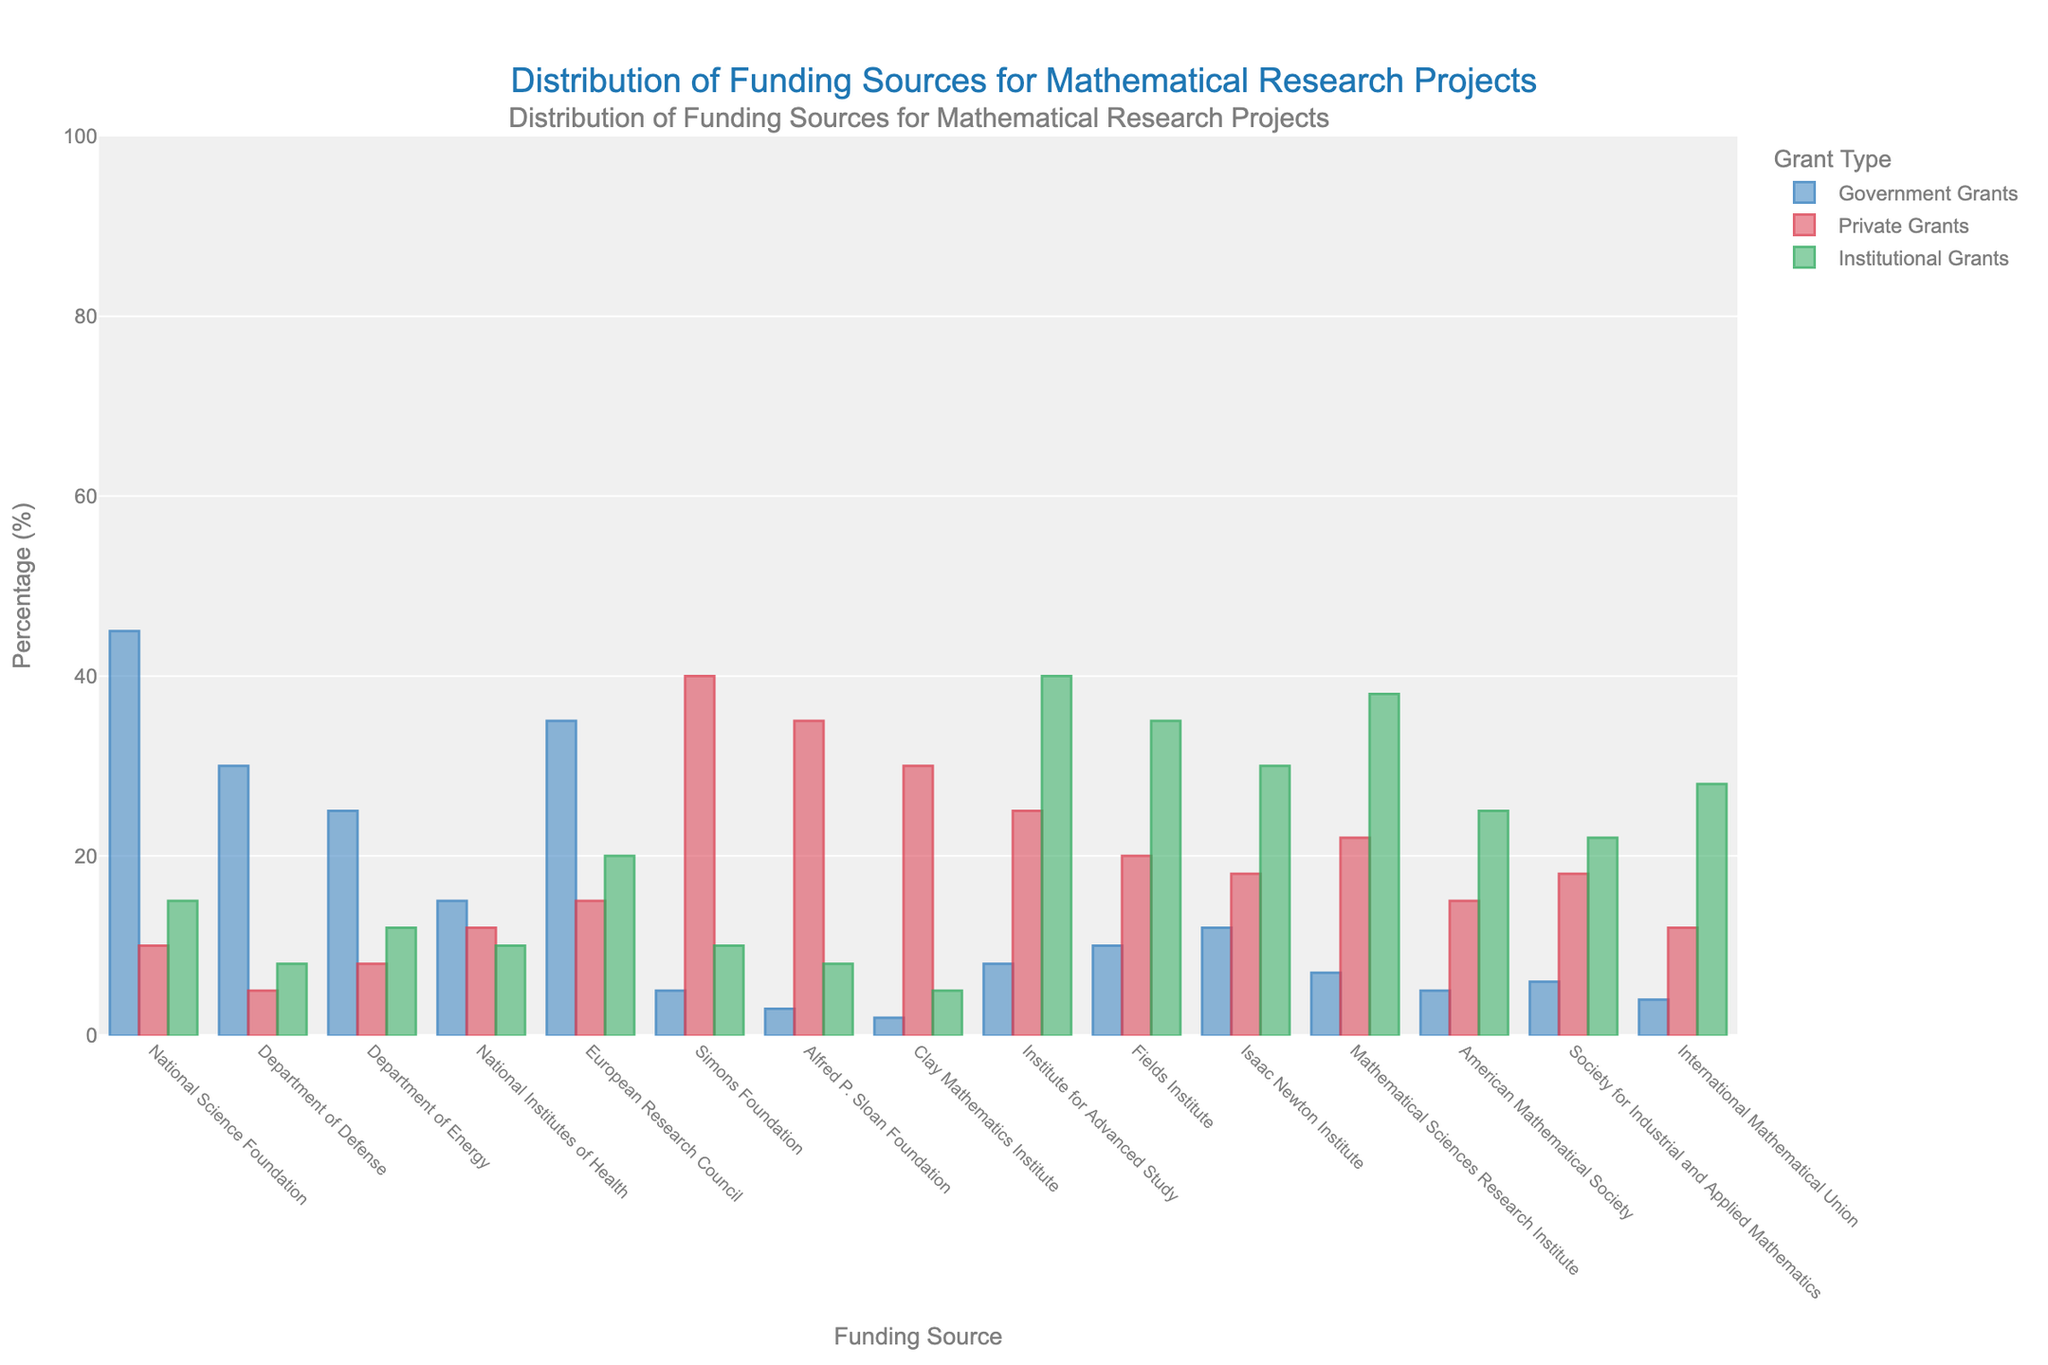Which funding source has the highest percentage of private grants? The bar representing the Simons Foundation has the tallest red bar, indicating the highest percentage of private grants at 40%.
Answer: Simons Foundation Which funding source has the lowest percentage of government grants? The bar representing the Clay Mathematics Institute has the shortest blue bar, indicating the lowest percentage of government grants at 2%.
Answer: Clay Mathematics Institute What is the total percentage of grants for the National Science Foundation combining all three sources? The percentages are 45% for government, 10% for private, and 15% for institutional grants. Adding these together, 45 + 10 + 15 = 70.
Answer: 70% Compare the percentage of institutional grants for the Institute for Advanced Study and Fields Institute. Which is higher and by how much? The Institute for Advanced Study has 40%, and the Fields Institute has 35%. The difference is 40 - 35 = 5.
Answer: Institute for Advanced Study by 5% Which funding source has an equal percentage of government and private grants? The bar representing the International Mathematical Union has 4% for both government and private grants, indicating equal percentages.
Answer: International Mathematical Union Which funding source has the highest percentage of institutional grants? The bar representing the Mathematical Sciences Research Institute has the tallest green bar, indicating the highest percentage of institutional grants at 38%.
Answer: Mathematical Sciences Research Institute What is the average percentage of government grants across all funding sources? Summing the government grant percentages: 45 + 30 + 25 + 15 + 35 + 5 + 3 + 2 + 8 + 10 + 12 + 7 + 5 + 6 + 4 = 212. There are 15 funding sources, so the average is 212 / 15 ≈ 14.13.
Answer: 14.13% Determine the percentage point difference between government grants for the National Science Foundation and the Department of Defense. The National Science Foundation has 45% in government grants, and the Department of Defense has 30%. The difference is 45 - 30 = 15.
Answer: 15% Which funding sources have more than 20% institutional grants and who are they? The funding sources with more than 20% institutional grants are the European Research Council (20%), Institute for Advanced Study (40%), Fields Institute (35%), Isaac Newton Institute (30%), Mathematical Sciences Research Institute (38%), American Mathematical Society (25%), and Society for Industrial and Applied Mathematics (22%).
Answer: European Research Council, Institute for Advanced Study, Fields Institute, Isaac Newton Institute, Mathematical Sciences Research Institute, American Mathematical Society, Society for Industrial and Applied Mathematics What is the sum of private grants percentages for the Simons Foundation and Alfred P. Sloan Foundation? The percentages for the Simons Foundation is 40% and for Alfred P. Sloan Foundation is 35%. Summing these, 40 + 35 = 75.
Answer: 75% 